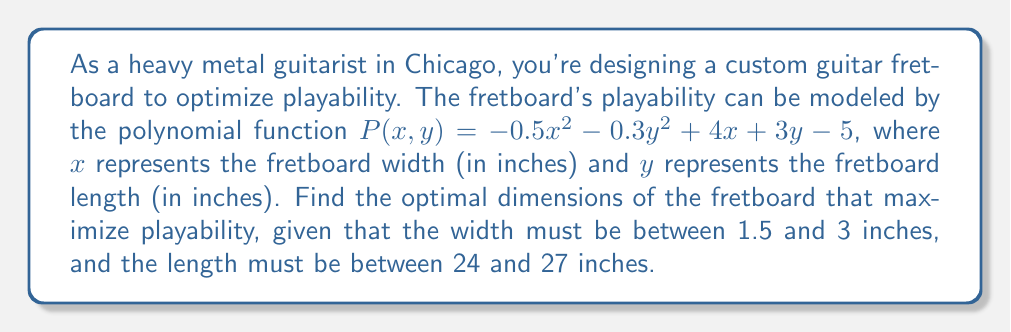Can you solve this math problem? To find the optimal dimensions that maximize playability, we need to find the maximum value of the function $P(x,y)$ within the given constraints. This is a polynomial optimization problem.

1. First, let's find the critical points by taking partial derivatives and setting them equal to zero:

   $$\frac{\partial P}{\partial x} = -x + 4 = 0$$
   $$\frac{\partial P}{\partial y} = -0.6y + 3 = 0$$

2. Solving these equations:
   $x = 4$ and $y = 5$

3. However, these values are outside our constraints. So, we need to check the boundaries of our constraints:

   Width constraints: $1.5 \leq x \leq 3$
   Length constraints: $24 \leq y \leq 27$

4. Let's evaluate $P(x,y)$ at each corner of our constraint rectangle:

   $P(1.5, 24) = -0.5(1.5)^2 - 0.3(24)^2 + 4(1.5) + 3(24) - 5 = 31.875$
   $P(1.5, 27) = -0.5(1.5)^2 - 0.3(27)^2 + 4(1.5) + 3(27) - 5 = 30.375$
   $P(3, 24) = -0.5(3)^2 - 0.3(24)^2 + 4(3) + 3(24) - 5 = 33.75$
   $P(3, 27) = -0.5(3)^2 - 0.3(27)^2 + 4(3) + 3(27) - 5 = 32.25$

5. The maximum value occurs at $(3, 24)$, which gives us the optimal dimensions within our constraints.

Therefore, the optimal fretboard width is 3 inches, and the optimal length is 24 inches.
Answer: The optimal dimensions for the guitar fretboard that maximize playability are:
Width: 3 inches
Length: 24 inches 